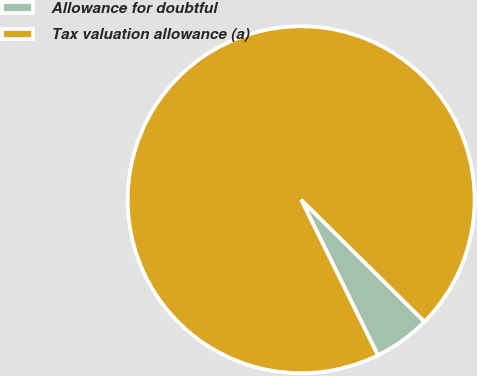Convert chart. <chart><loc_0><loc_0><loc_500><loc_500><pie_chart><fcel>Allowance for doubtful<fcel>Tax valuation allowance (a)<nl><fcel>5.3%<fcel>94.7%<nl></chart> 